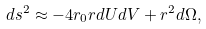Convert formula to latex. <formula><loc_0><loc_0><loc_500><loc_500>d s ^ { 2 } \approx - 4 r _ { 0 } r d U d V + r ^ { 2 } d \Omega ,</formula> 